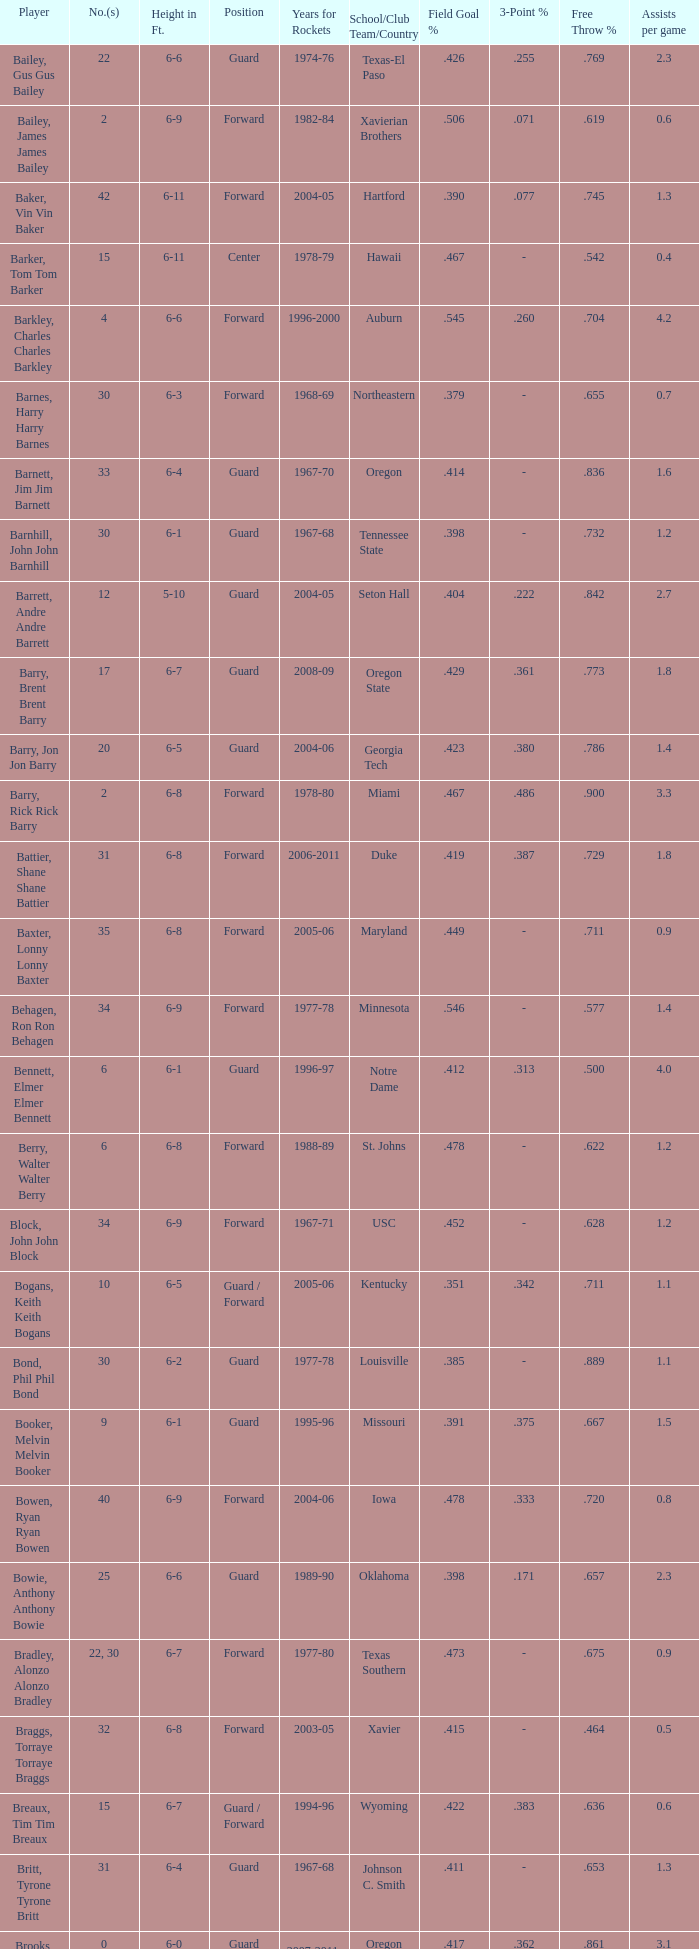What years did the player from LaSalle play for the Rockets? 1982-83. 